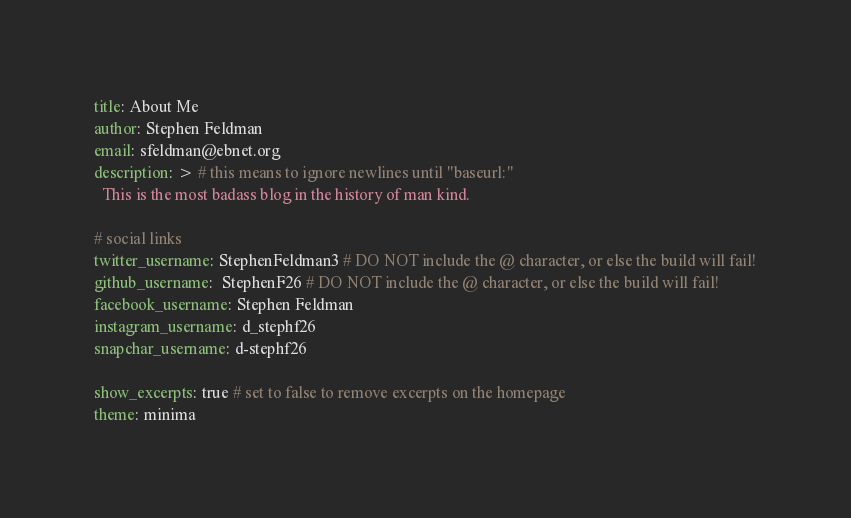Convert code to text. <code><loc_0><loc_0><loc_500><loc_500><_YAML_>title: About Me
author: Stephen Feldman
email: sfeldman@ebnet.org
description: > # this means to ignore newlines until "baseurl:"
  This is the most badass blog in the history of man kind.

# social links
twitter_username: StephenFeldman3 # DO NOT include the @ character, or else the build will fail!
github_username:  StephenF26 # DO NOT include the @ character, or else the build will fail!
facebook_username: Stephen Feldman
instagram_username: d_stephf26
snapchar_username: d-stephf26

show_excerpts: true # set to false to remove excerpts on the homepage
theme: minima
</code> 